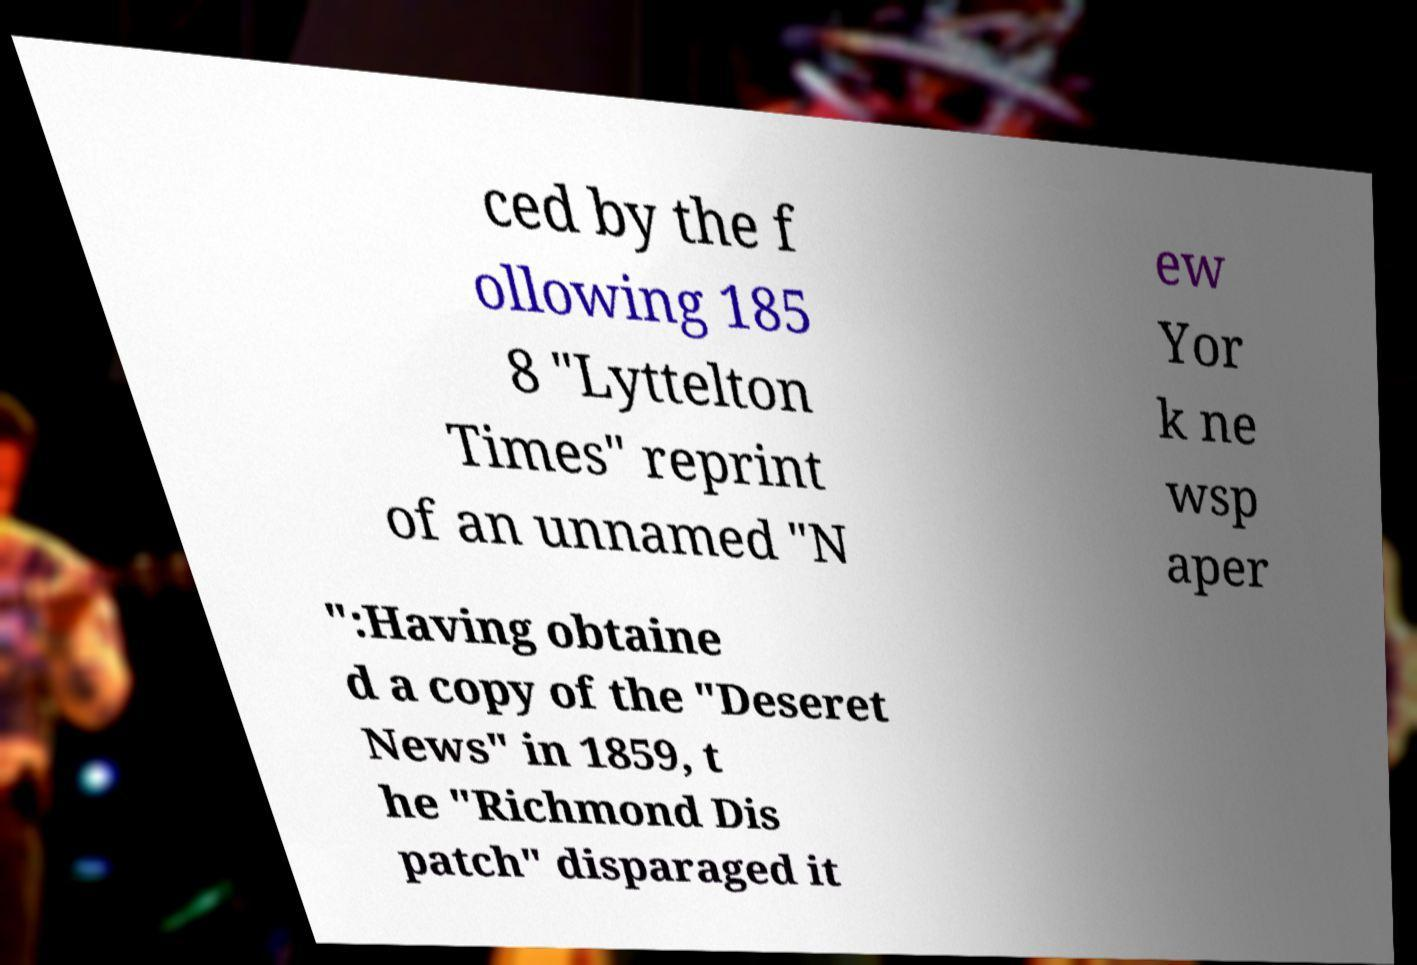Can you read and provide the text displayed in the image?This photo seems to have some interesting text. Can you extract and type it out for me? ced by the f ollowing 185 8 "Lyttelton Times" reprint of an unnamed "N ew Yor k ne wsp aper ":Having obtaine d a copy of the "Deseret News" in 1859, t he "Richmond Dis patch" disparaged it 